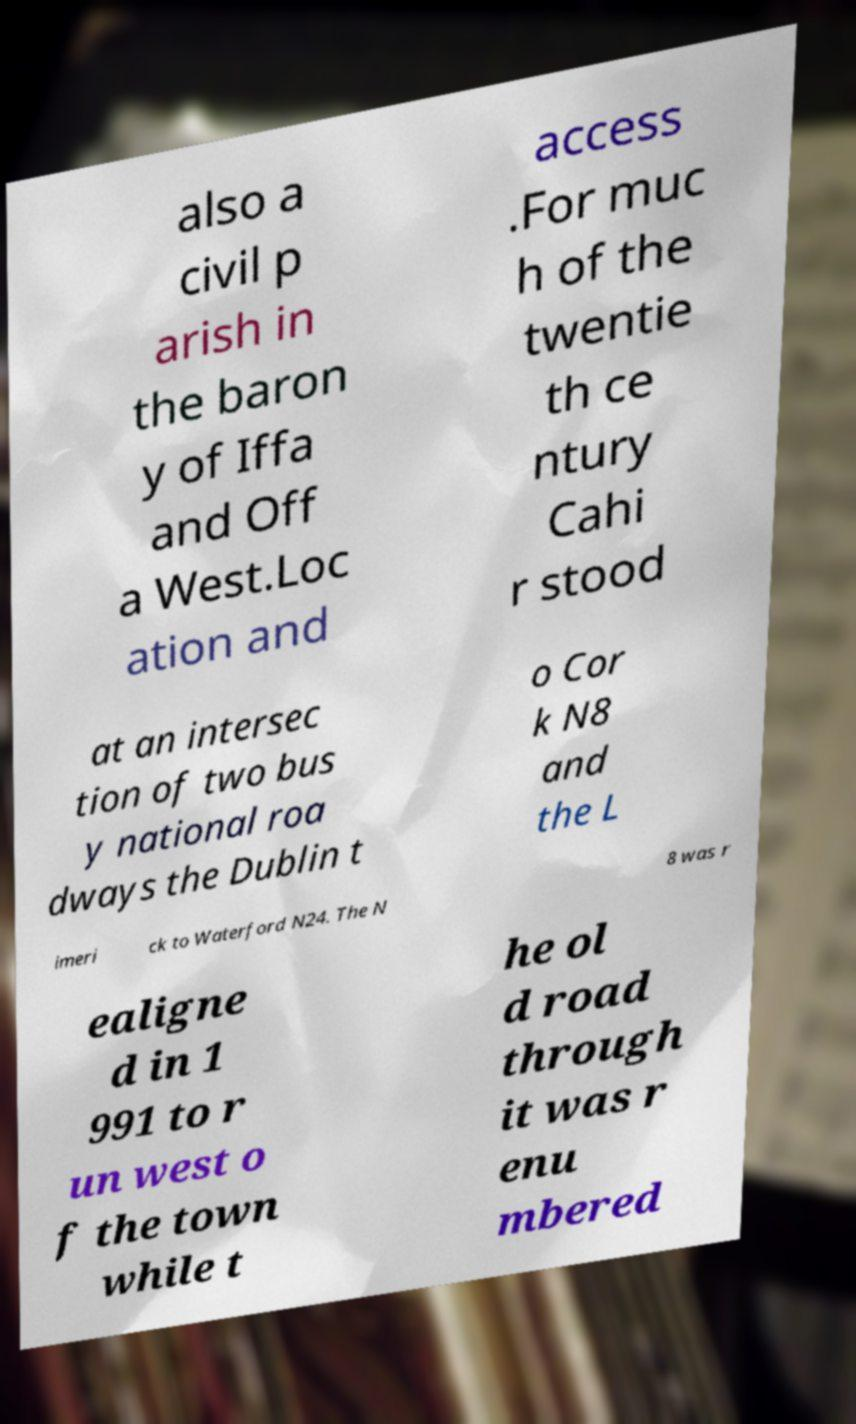I need the written content from this picture converted into text. Can you do that? also a civil p arish in the baron y of Iffa and Off a West.Loc ation and access .For muc h of the twentie th ce ntury Cahi r stood at an intersec tion of two bus y national roa dways the Dublin t o Cor k N8 and the L imeri ck to Waterford N24. The N 8 was r ealigne d in 1 991 to r un west o f the town while t he ol d road through it was r enu mbered 